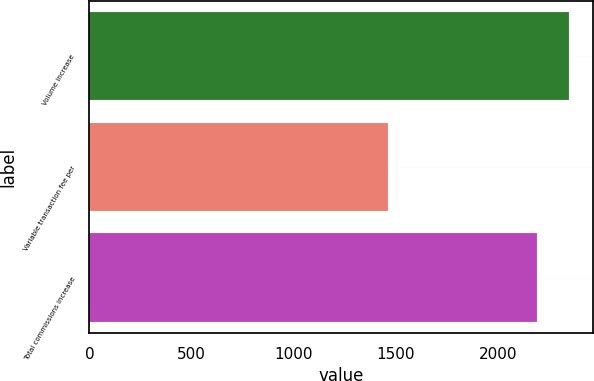<chart> <loc_0><loc_0><loc_500><loc_500><bar_chart><fcel>Volume increase<fcel>Variable transaction fee per<fcel>Total commissions increase<nl><fcel>2348<fcel>1462<fcel>2193<nl></chart> 